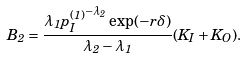Convert formula to latex. <formula><loc_0><loc_0><loc_500><loc_500>B _ { 2 } = \frac { \lambda _ { 1 } { p _ { I } ^ { ( 1 ) } } ^ { - \lambda _ { 2 } } \exp ( - r \delta ) } { \lambda _ { 2 } - \lambda _ { 1 } } ( K _ { I } + K _ { O } ) .</formula> 